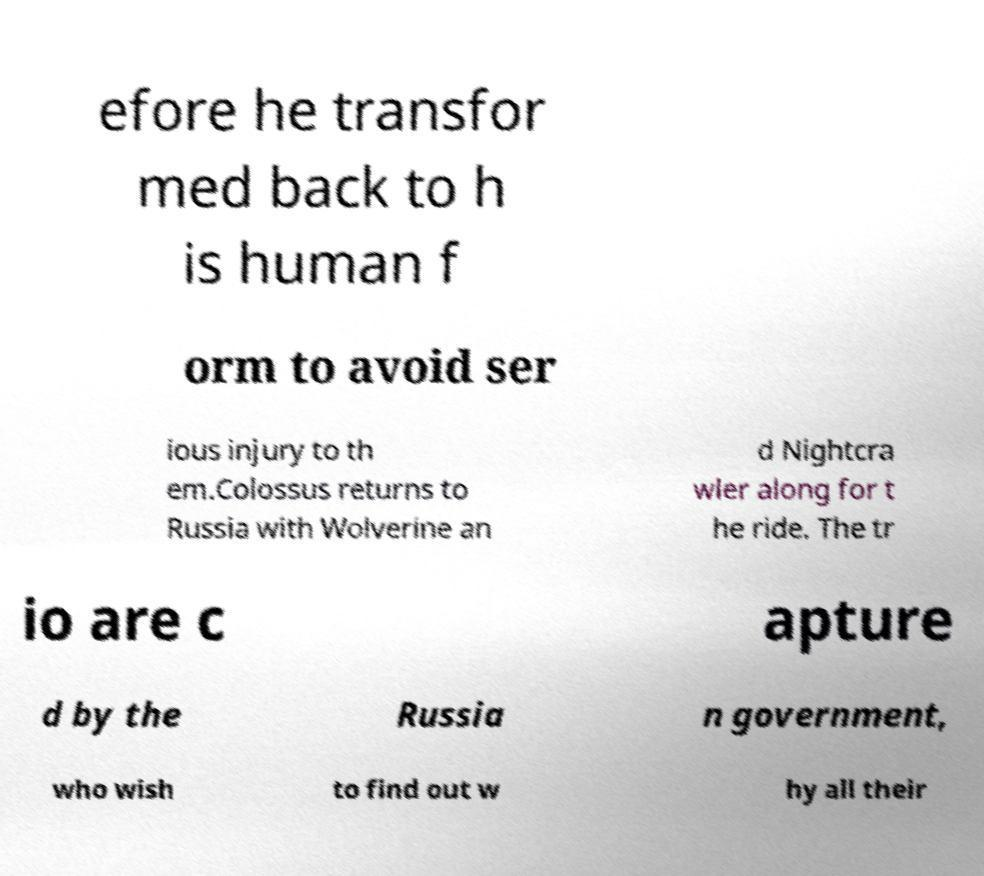What messages or text are displayed in this image? I need them in a readable, typed format. efore he transfor med back to h is human f orm to avoid ser ious injury to th em.Colossus returns to Russia with Wolverine an d Nightcra wler along for t he ride. The tr io are c apture d by the Russia n government, who wish to find out w hy all their 